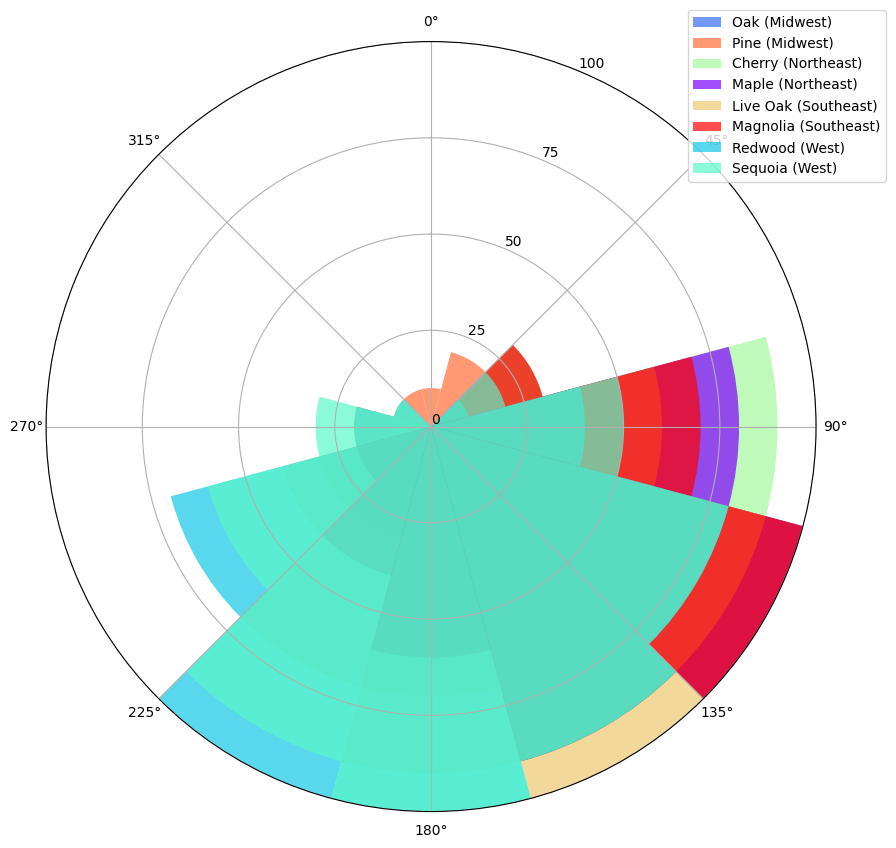Which tree species has the highest blooming intensity in August in the West region? In the West region, the Redwood and Sequoia trees are both shown. By observing the height of their respective bars in August, we see both the Redwood and Sequoia have intense and high bars.
Answer: Redwood and Sequoia Which region has the most intense blooming season in April overall? To determine this, we compare all regions' bars for all tree species in the month of April. The Northeast (Maple and Cherry), Midwest (Oak and Pine), Southeast (Live Oak and Magnolia), and West (Redwood and Sequoia) are examined. The Midwest Pine shows a prominent bar as does the Southeast with Live Oak and Magnolia. The Southeast has two high bars while others have just one or lower.
Answer: Southeast Identify the month with the highest blooming intensity for the Live Oak in the Southeast region. This can be found by looking at the bars' heights for Live Oak in each month. June has the tallest bar.
Answer: June How does the blooming intensity of Cherry in the Northeast compare between March and July? To answer this, we compare the height of the bars for Cherry in March and July in the Northeast. In March, the height is considerably lower than in July.
Answer: March is less than July What's the combined blooming intensity of the Magnolia in the Southeast region for the months of April and May? For the Magnolia in the Southeast, look at the heights of the bars for April and May, which are 70 and 100, respectively. Adding these together gives 170.
Answer: 170 During which months does the Pine in the Midwest region have a blooming intensity greater than or equal to 70? Reviewing the bar lengths for Pine in each month for the Midwest, we see May, June, and July meet or exceed 70.
Answer: May, June, July Which tree species has a longer blooming period, Maple in the Northeast or Redwood in the West? The Maple in the Northeast blooms significantly from March to September, while the Redwood in the West shows significant bloom from March to September as well but with higher intensities for longer months. This indicates that Redwood's bloom intensity remains high for a longer period.
Answer: Redwood What is the average blooming intensity for Sequoias in the West during summer months (June, July, August)? For Sequoias in the West, the intensities in June (90), July (100), and August (90) are summed up and divided by 3. This calculation results in (90 + 100 + 90) / 3 = 280 / 3 ≈ 93.33.
Answer: 93.33 During which months is there no blooming activity for Oak in the Midwest? By examining the bar heights for Oak in the Midwest, we note months with zero bar height. These months are January, February, October, November, and December.
Answer: January, February, October, November, December Comparing all regions, which has the most consistent blooming intensity for any tree species throughout the year? Consistent blooming would show less variation in bar height throughout the year. Observing the provided data, we notice the Pine in the Midwest has the most even distribution of blooming intensity across the months, though it varies moderately.
Answer: Midwest Pine 